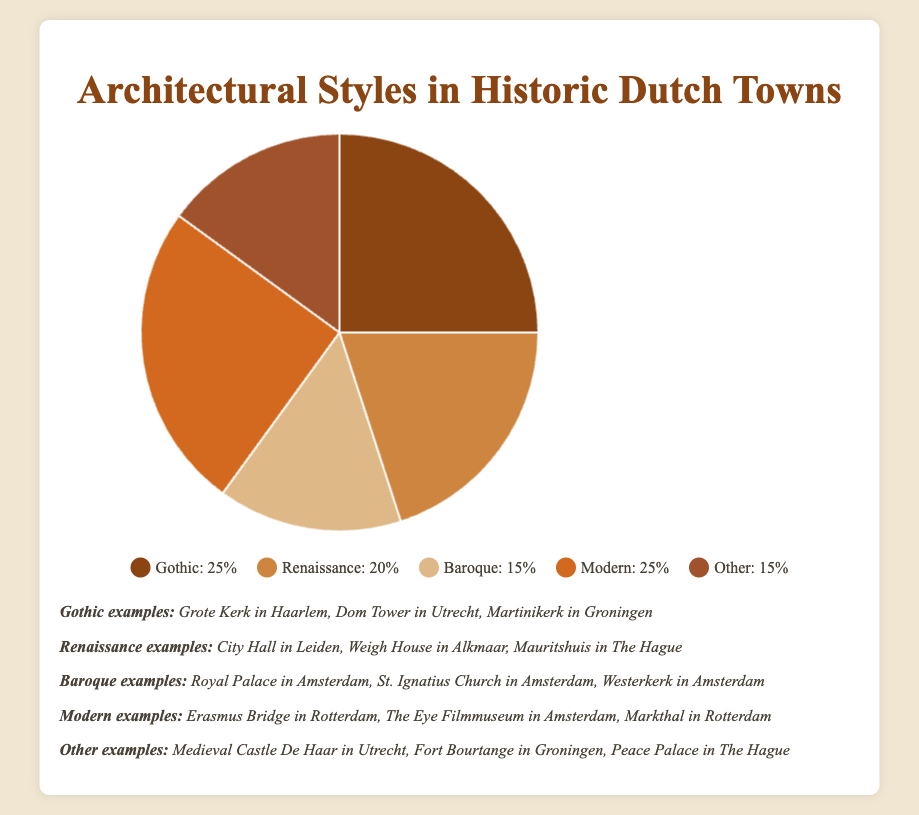Which architectural style shares the highest percentage along with Modern? Gothic and Modern each has 25% share as shown in the pie chart.
Answer: Gothic What is the difference in percentage between Gothic and Baroque styles? Gothic has 25% and Baroque has 15%. The difference is 25% - 15% = 10%.
Answer: 10% Which styles cover exactly 15% of the architectural representation? Baroque and Other styles both are depicted with 15% in the pie chart.
Answer: Baroque and Other How do the sums of the percentages of Renaissance and Other styles compare to that of Baroque and Gothic styles? Renaissance and Other together sum up to 20% + 15% = 35% and Baroque and Gothic sum up to 15% + 25% = 40%. The sum of Renaissance and Other is less than the sum of Baroque and Gothic.
Answer: Less than What percentage of historic Dutch architecture is represented by styles other than Gothic and Modern? Gothic and Modern each is 25%, so their combined is 50%. The remaining percentage is 100% - 50% = 50%.
Answer: 50% Which architectural style is represented by dark brown on the pie chart? The style with 25% representation is Gothic, shown in dark brown.
Answer: Gothic If the sum of percentages of Modern and Renaissance styles is divided in a \(3:2\) ratio, what are the resulting shares? Modern is 25%, Renaissance is 20%, so their sum is 45%. To divide by \(3:2\), we do \(45 \div 5 = 9\), so \(3 \times 9 = 27\) and \(2 \times 9 = 18\). The resulting shares are 27% and 18%.
Answer: 27% and 18% What is the combined percentage of the styles identified with warm color shades? Warm color shades in the pie chart correspond to Gothic, Renaissance, and Baroque (25% + 20% + 15%). Their combined percentage is 60%.
Answer: 60% If you were to combine the Baroque and Other styles, would they surpass the Modern style in percentage? Baroque and Other styles combined are 15% + 15% = 30%, which is more than the 25% for Modern style.
Answer: Yes 